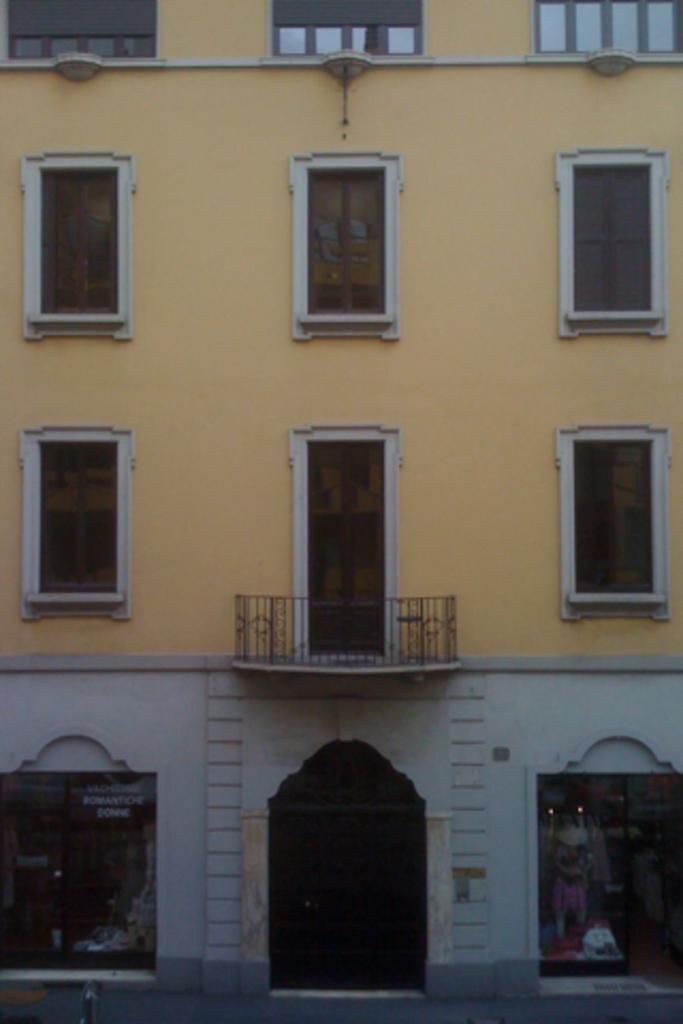Please provide a concise description of this image. In this image, I can see a building, windows, doors, board and shops. This picture might be taken in a day. 